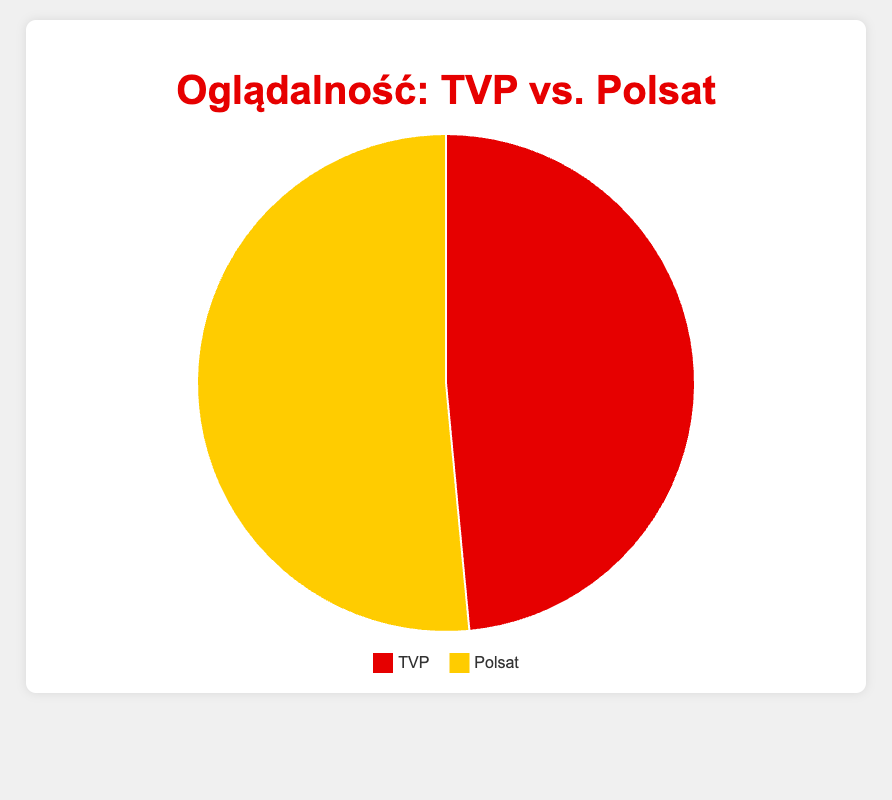What is the percentage of viewership for TVP? Look at the pie chart and find the red segment labeled "TVP."
Answer: 48.5% Which channel has the higher viewership percentage, TVP or Polsat? Compare the viewership percentages of TVP and Polsat from the pie chart.
Answer: Polsat By how much does Polsat's viewership exceed TVP's? Subtract TVP's viewership percentage from Polsat's: 51.5% - 48.5% = 3%
Answer: 3% What is the total viewership percentage represented in the pie chart? Since there are only two segments representing TVP and Polsat, their percentages sum up to 100%.
Answer: 100% Which color represents TVP in the pie chart? Identify the segment associated with TVP and its color.
Answer: Red If you were to convert each percentage into a fraction, what would be the fraction for Polsat’s viewership? Polsat's percentage is 51.5%. Converting it into a fraction: 51.5% = 51.5/100 = 103/200
Answer: 103/200 What is the ratio of Polsat’s viewership to TVP’s viewership? Divide Polsat's percentage by TVP's percentage: 51.5% / 48.5% ≈ 1.06
Answer: 1.06 How many segments are there in the pie chart, and what do they represent? Count the segments and identify the labels.
Answer: 2 segments, TVP and Polsat If 10 viewers were sampled, how many would be watching TVP based on the percentages? Use TVP's percentage to find the number of viewers: 48.5% of 10 viewers = 0.485 * 10 = 4.85, which rounds to approximately 5 viewers.
Answer: Approximately 5 viewers Which segment is larger and by what visual attribute can it be identified? Identify the segment that takes up more space in the pie chart; the yellow segment (Polsat) is larger.
Answer: Yellow segment 